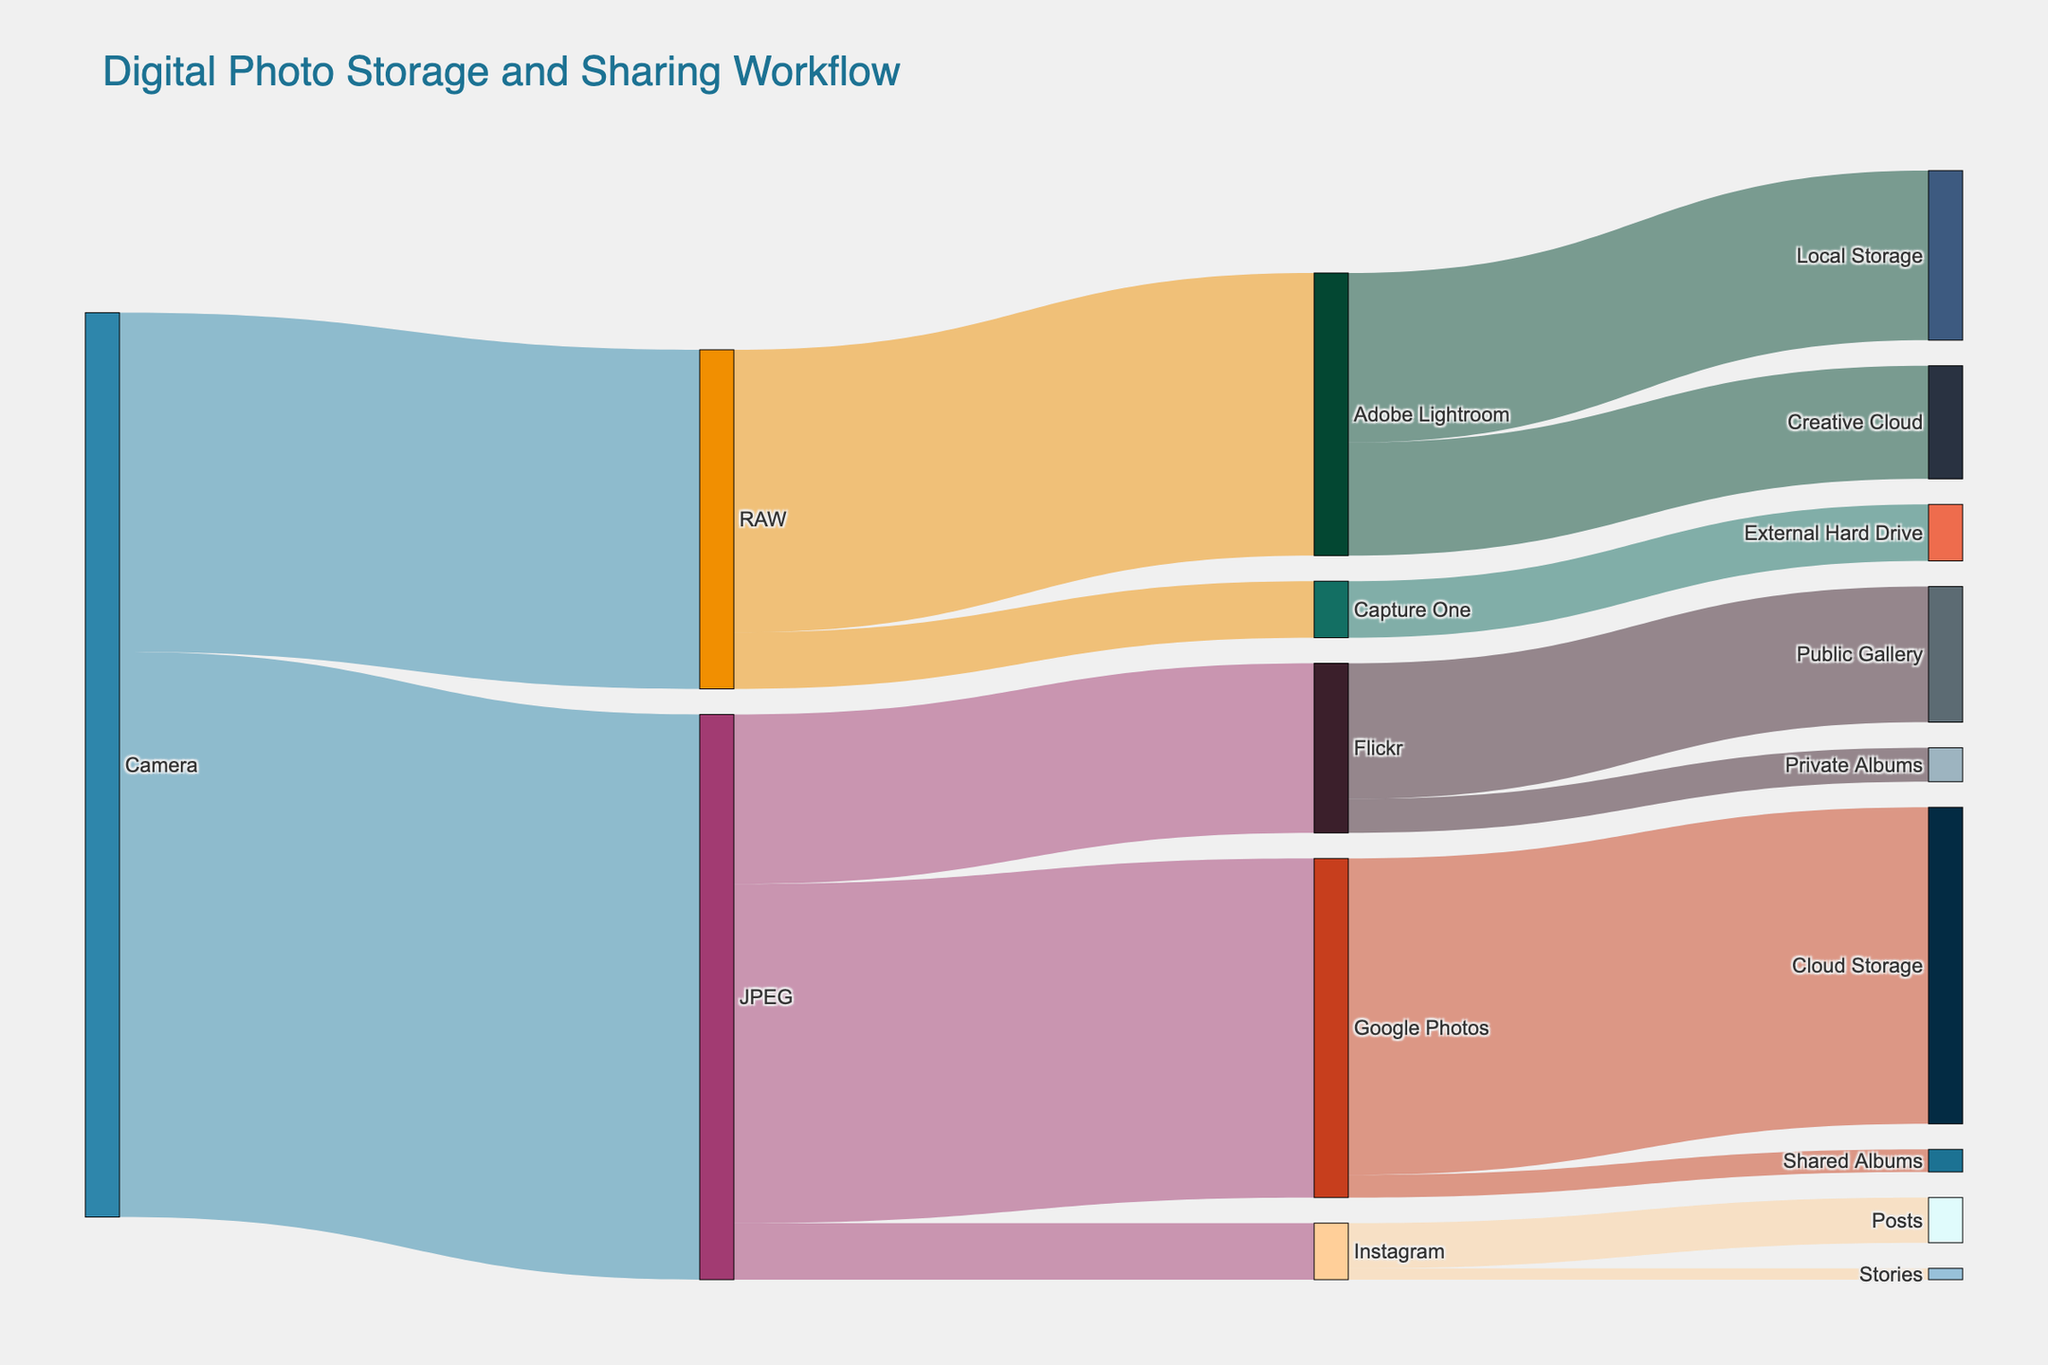What is the title of the Sankey Diagram? The title is displayed at the top center of the diagram.
Answer: Digital Photo Storage and Sharing Workflow Which file type has the highest initial value from the Camera? Look for the highest number in the initial connections coming from the Camera node.
Answer: JPEG How many photos are stored in Google Photos from JPEG files? Identify the connection from the JPEG node to the Google Photos node and note the value.
Answer: 3000 What is the total number of files that end up in Adobe Lightroom? Sum the values of all connections leading to Adobe Lightroom.
Answer: 2500 Which platform has more photos stored, Google Photos or Flickr? Compare the total incoming values for Google Photos and Flickr nodes.
Answer: Google Photos How many more photos are processed as JPEGs compared to RAWs initially from the Camera? Subtract the value of the RAW connection from the value of the JPEG connection from the Camera.
Answer: 2000 What is the sum of the photos shared in Instagram Posts and Stories? Add the values for the connections going from Instagram to Posts and Stories.
Answer: 500 Which has more storage, Local Storage or Creative Cloud within Adobe Lightroom? Compare the values of Local Storage and Creative Cloud connections from Adobe Lightroom.
Answer: Local Storage Are there more photos in Private Albums or Public Gallery in Flickr? Compare the values of connections from Flickr to Private Albums and Public Gallery.
Answer: Public Gallery What percentage of Google Photos files are stored in Cloud Storage? Divide the value for Cloud Storage by the total photos in Google Photos and multiply by 100.
Answer: 93.33% (2800 out of 3000) 